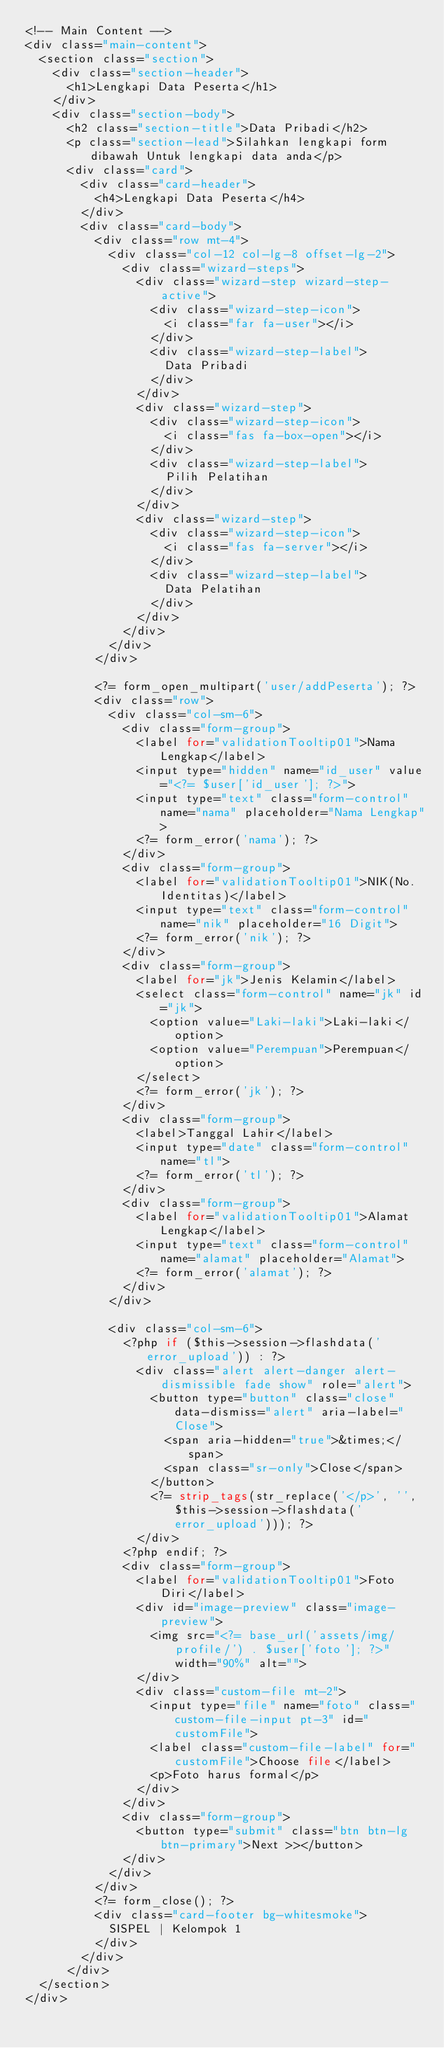<code> <loc_0><loc_0><loc_500><loc_500><_PHP_><!-- Main Content -->
<div class="main-content">
  <section class="section">
    <div class="section-header">
      <h1>Lengkapi Data Peserta</h1>
    </div>
    <div class="section-body">
      <h2 class="section-title">Data Pribadi</h2>
      <p class="section-lead">Silahkan lengkapi form dibawah Untuk lengkapi data anda</p>
      <div class="card">
        <div class="card-header">
          <h4>Lengkapi Data Peserta</h4>
        </div>
        <div class="card-body">
          <div class="row mt-4">
            <div class="col-12 col-lg-8 offset-lg-2">
              <div class="wizard-steps">
                <div class="wizard-step wizard-step-active">
                  <div class="wizard-step-icon">
                    <i class="far fa-user"></i>
                  </div>
                  <div class="wizard-step-label">
                    Data Pribadi
                  </div>
                </div>
                <div class="wizard-step">
                  <div class="wizard-step-icon">
                    <i class="fas fa-box-open"></i>
                  </div>
                  <div class="wizard-step-label">
                    Pilih Pelatihan
                  </div>
                </div>
                <div class="wizard-step">
                  <div class="wizard-step-icon">
                    <i class="fas fa-server"></i>
                  </div>
                  <div class="wizard-step-label">
                    Data Pelatihan
                  </div>
                </div>
              </div>
            </div>
          </div>

          <?= form_open_multipart('user/addPeserta'); ?>
          <div class="row">
            <div class="col-sm-6">
              <div class="form-group">
                <label for="validationTooltip01">Nama Lengkap</label>
                <input type="hidden" name="id_user" value="<?= $user['id_user']; ?>">
                <input type="text" class="form-control" name="nama" placeholder="Nama Lengkap">
                <?= form_error('nama'); ?>
              </div>
              <div class="form-group">
                <label for="validationTooltip01">NIK(No.Identitas)</label>
                <input type="text" class="form-control" name="nik" placeholder="16 Digit">
                <?= form_error('nik'); ?>
              </div>
              <div class="form-group">
                <label for="jk">Jenis Kelamin</label>
                <select class="form-control" name="jk" id="jk">
                  <option value="Laki-laki">Laki-laki</option>
                  <option value="Perempuan">Perempuan</option>
                </select>
                <?= form_error('jk'); ?>
              </div>
              <div class="form-group">
                <label>Tanggal Lahir</label>
                <input type="date" class="form-control" name="tl">
                <?= form_error('tl'); ?>
              </div>
              <div class="form-group">
                <label for="validationTooltip01">Alamat Lengkap</label>
                <input type="text" class="form-control" name="alamat" placeholder="Alamat">
                <?= form_error('alamat'); ?>
              </div>
            </div>

            <div class="col-sm-6">
              <?php if ($this->session->flashdata('error_upload')) : ?>
                <div class="alert alert-danger alert-dismissible fade show" role="alert">
                  <button type="button" class="close" data-dismiss="alert" aria-label="Close">
                    <span aria-hidden="true">&times;</span>
                    <span class="sr-only">Close</span>
                  </button>
                  <?= strip_tags(str_replace('</p>', '', $this->session->flashdata('error_upload'))); ?>
                </div>
              <?php endif; ?>
              <div class="form-group">
                <label for="validationTooltip01">Foto Diri</label>
                <div id="image-preview" class="image-preview">
                  <img src="<?= base_url('assets/img/profile/') . $user['foto']; ?>" width="90%" alt="">
                </div>
                <div class="custom-file mt-2">
                  <input type="file" name="foto" class="custom-file-input pt-3" id="customFile">
                  <label class="custom-file-label" for="customFile">Choose file</label>
                  <p>Foto harus formal</p>
                </div>
              </div>
              <div class="form-group">
                <button type="submit" class="btn btn-lg btn-primary">Next >></button>
              </div>
            </div>
          </div>
          <?= form_close(); ?>
          <div class="card-footer bg-whitesmoke">
            SISPEL | Kelompok 1
          </div>
        </div>
      </div>
  </section>
</div></code> 